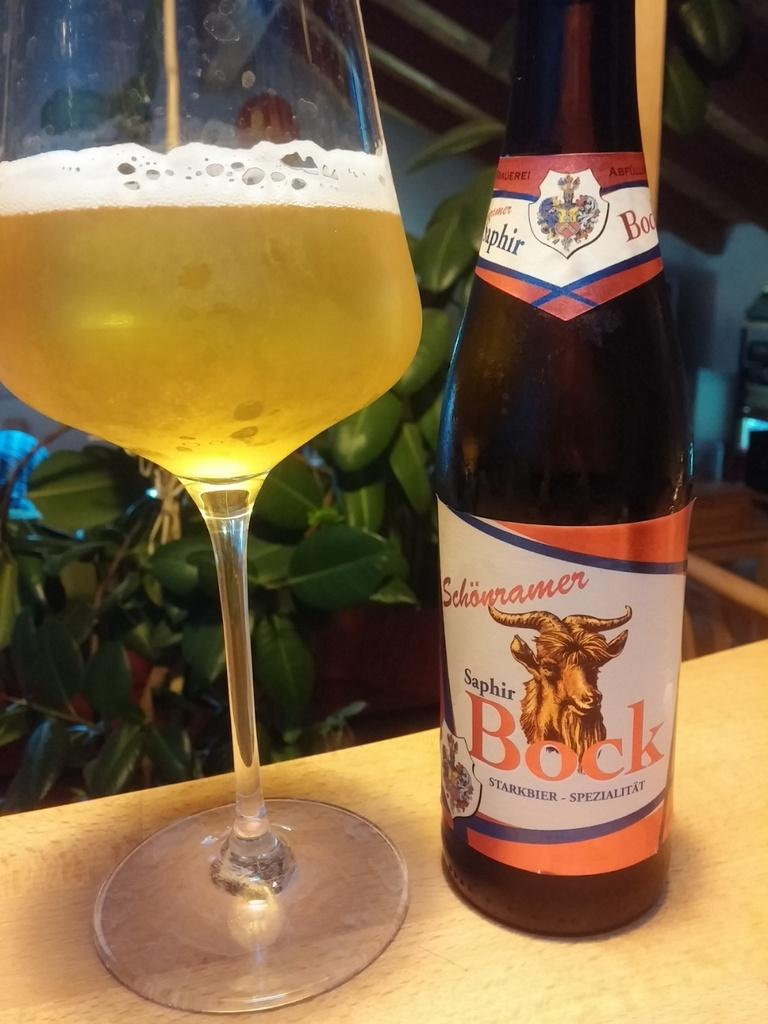Provide a one-sentence caption for the provided image. A bottle of Bock booze next to a glass of liquid. 